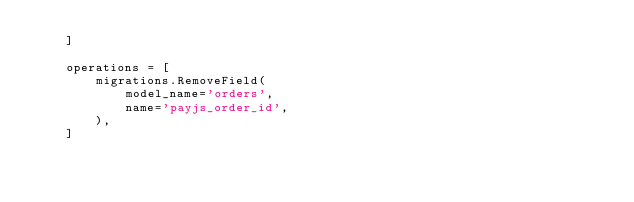<code> <loc_0><loc_0><loc_500><loc_500><_Python_>    ]

    operations = [
        migrations.RemoveField(
            model_name='orders',
            name='payjs_order_id',
        ),
    ]
</code> 